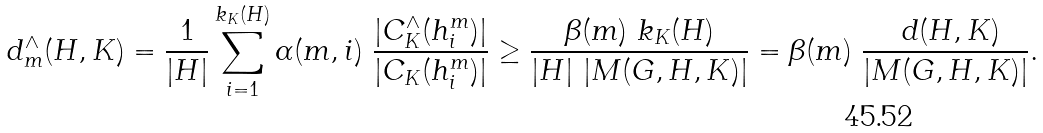<formula> <loc_0><loc_0><loc_500><loc_500>d ^ { \wedge } _ { m } ( H , K ) = \frac { 1 } { | H | } \sum ^ { k _ { K } ( H ) } _ { i = 1 } \alpha ( m , i ) \ \frac { | C ^ { \wedge } _ { K } ( h ^ { m } _ { i } ) | } { | C _ { K } ( h ^ { m } _ { i } ) | } \geq \frac { \beta ( m ) \ k _ { K } ( H ) } { | H | \ | M ( G , H , K ) | } = \beta ( m ) \ \frac { \ d ( H , K ) } { | M ( G , H , K ) | } .</formula> 